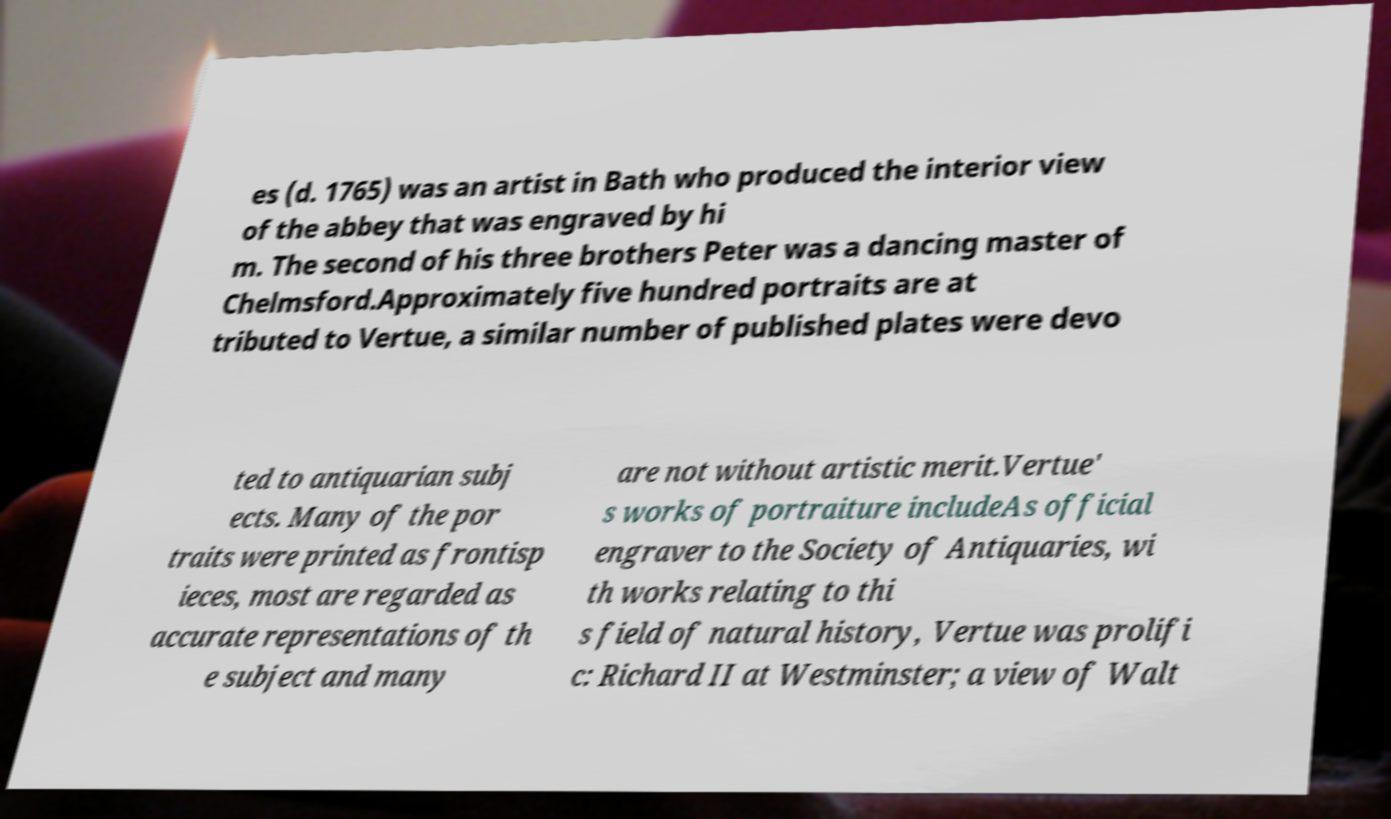Please identify and transcribe the text found in this image. es (d. 1765) was an artist in Bath who produced the interior view of the abbey that was engraved by hi m. The second of his three brothers Peter was a dancing master of Chelmsford.Approximately five hundred portraits are at tributed to Vertue, a similar number of published plates were devo ted to antiquarian subj ects. Many of the por traits were printed as frontisp ieces, most are regarded as accurate representations of th e subject and many are not without artistic merit.Vertue' s works of portraiture includeAs official engraver to the Society of Antiquaries, wi th works relating to thi s field of natural history, Vertue was prolifi c: Richard II at Westminster; a view of Walt 